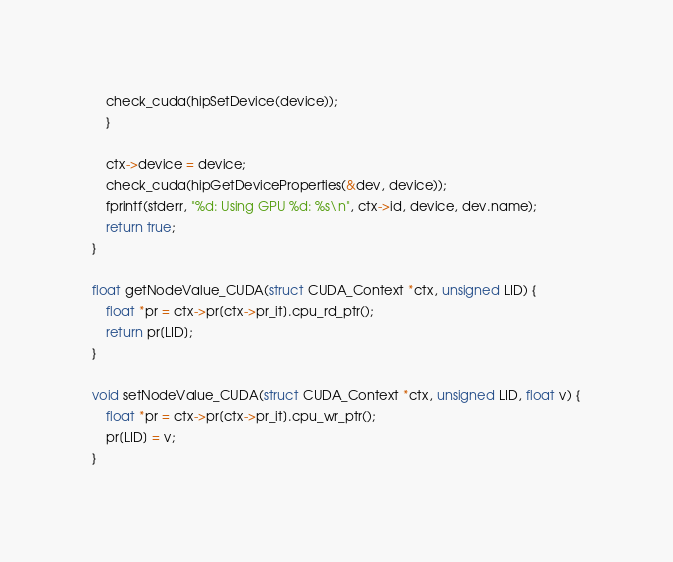Convert code to text. <code><loc_0><loc_0><loc_500><loc_500><_Cuda_>    check_cuda(hipSetDevice(device));
    }
  
    ctx->device = device;
    check_cuda(hipGetDeviceProperties(&dev, device));
    fprintf(stderr, "%d: Using GPU %d: %s\n", ctx->id, device, dev.name);
    return true;
}

float getNodeValue_CUDA(struct CUDA_Context *ctx, unsigned LID) {
    float *pr = ctx->pr[ctx->pr_it].cpu_rd_ptr();
    return pr[LID];
}

void setNodeValue_CUDA(struct CUDA_Context *ctx, unsigned LID, float v) {
    float *pr = ctx->pr[ctx->pr_it].cpu_wr_ptr();
    pr[LID] = v;
}
</code> 